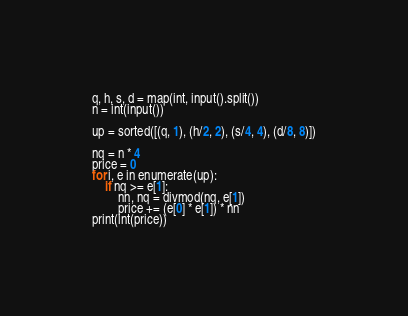<code> <loc_0><loc_0><loc_500><loc_500><_Python_>q, h, s, d = map(int, input().split())
n = int(input())

up = sorted([(q, 1), (h/2, 2), (s/4, 4), (d/8, 8)])

nq = n * 4
price = 0
for i, e in enumerate(up):
    if nq >= e[1]:
        nn, nq = divmod(nq, e[1])
        price += (e[0] * e[1]) * nn
print(int(price))
</code> 